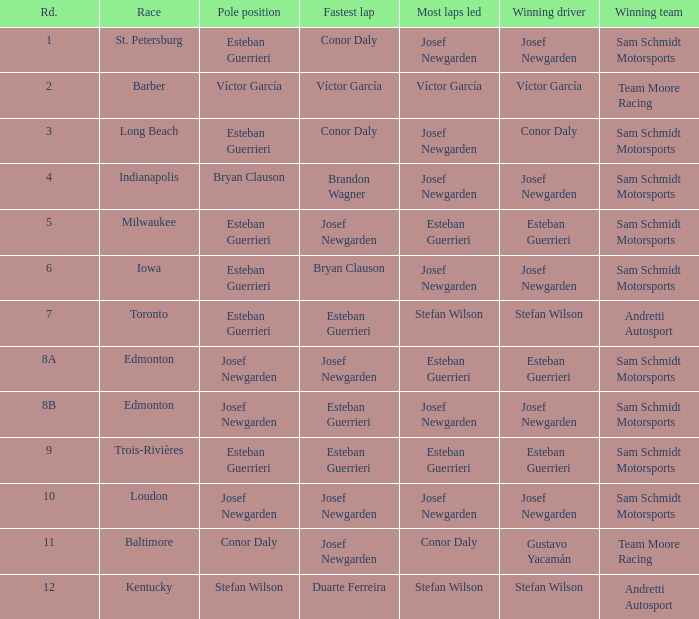Who had the fastest lap(s) when stefan wilson had the pole? Duarte Ferreira. 